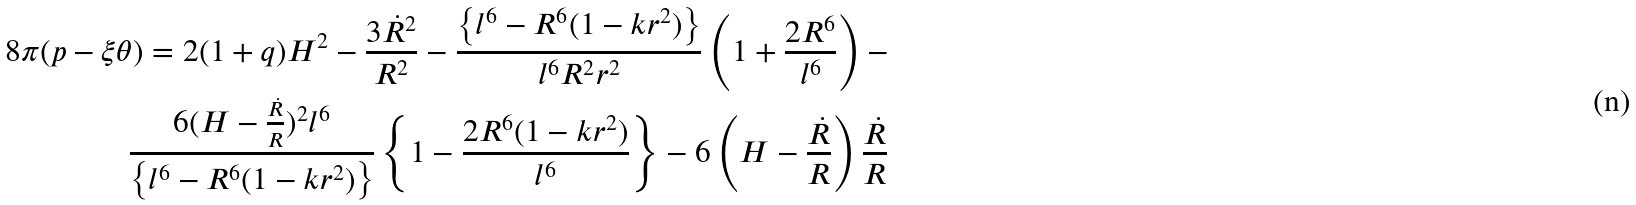<formula> <loc_0><loc_0><loc_500><loc_500>8 \pi ( p - \xi \theta ) = 2 ( 1 + q ) H ^ { 2 } - \frac { 3 \dot { R } ^ { 2 } } { R ^ { 2 } } - \frac { \left \{ l ^ { 6 } - R ^ { 6 } ( 1 - k r ^ { 2 } ) \right \} } { l ^ { 6 } R ^ { 2 } r ^ { 2 } } \left ( 1 + \frac { 2 R ^ { 6 } } { l ^ { 6 } } \right ) - \\ \frac { 6 ( H - \frac { \dot { R } } { R } ) ^ { 2 } l ^ { 6 } } { \left \{ l ^ { 6 } - R ^ { 6 } ( 1 - k r ^ { 2 } ) \right \} } \left \{ 1 - \frac { 2 R ^ { 6 } ( 1 - k r ^ { 2 } ) } { l ^ { 6 } } \right \} - 6 \left ( H - \frac { \dot { R } } { R } \right ) \frac { \dot { R } } { R }</formula> 